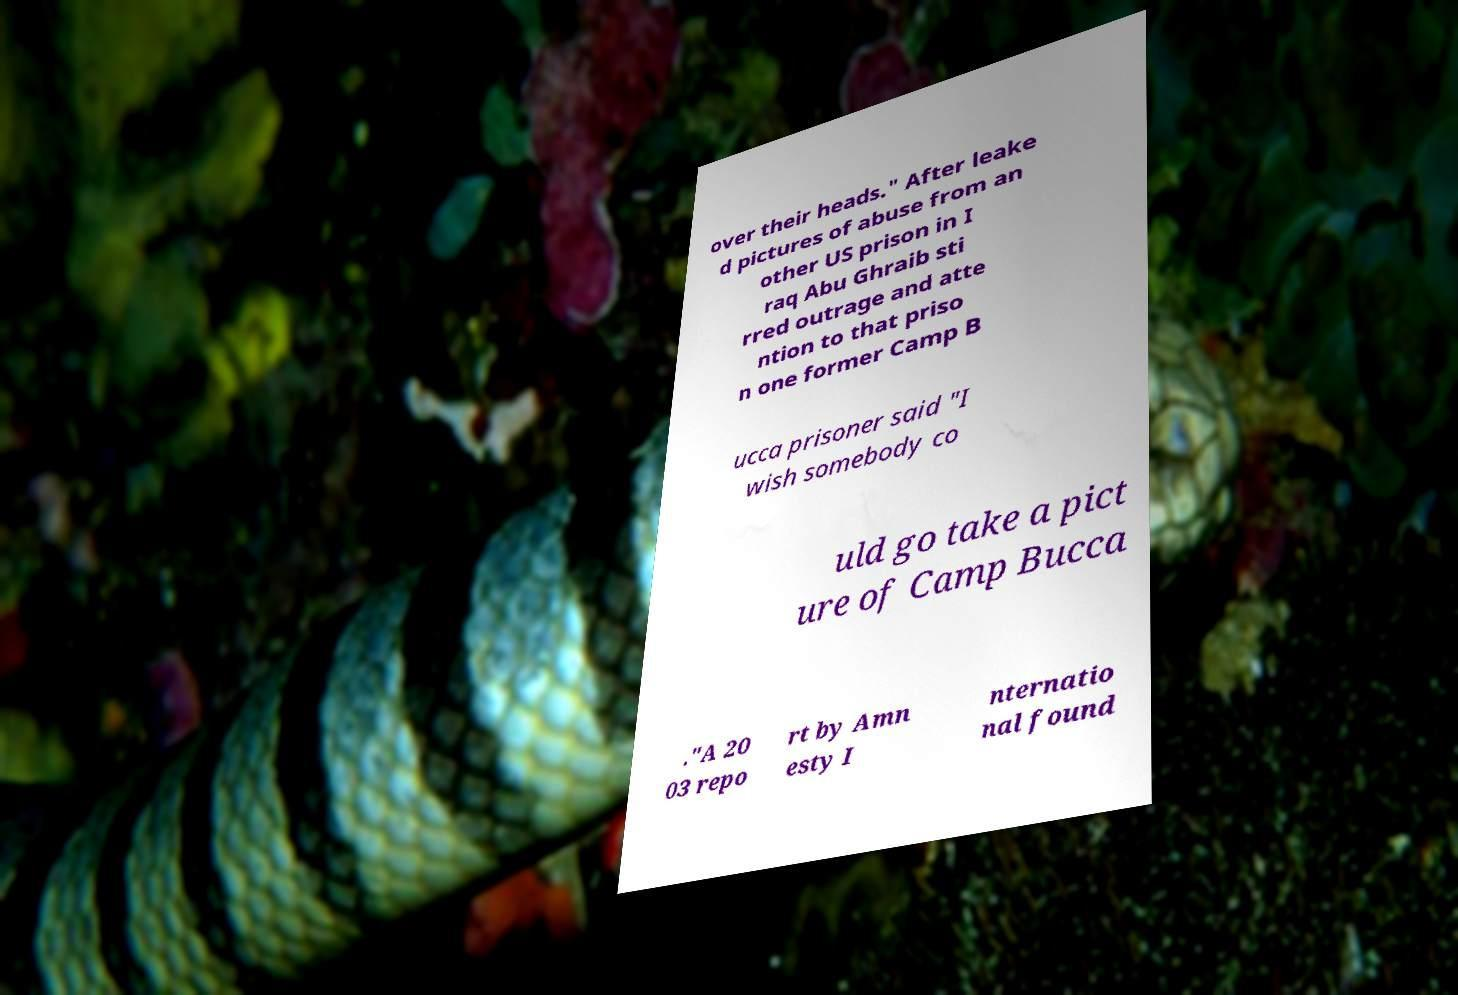What messages or text are displayed in this image? I need them in a readable, typed format. over their heads." After leake d pictures of abuse from an other US prison in I raq Abu Ghraib sti rred outrage and atte ntion to that priso n one former Camp B ucca prisoner said "I wish somebody co uld go take a pict ure of Camp Bucca ."A 20 03 repo rt by Amn esty I nternatio nal found 